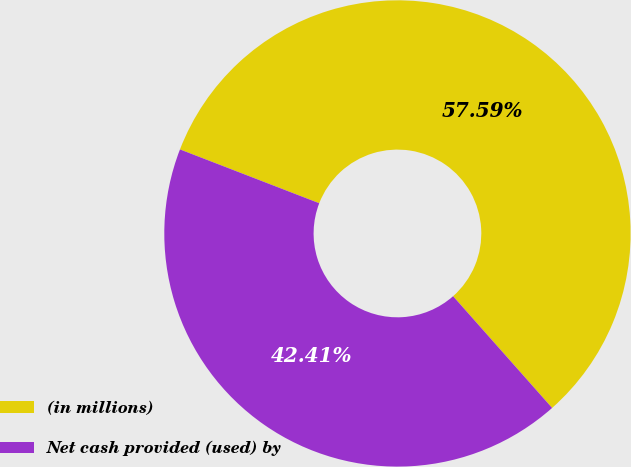Convert chart to OTSL. <chart><loc_0><loc_0><loc_500><loc_500><pie_chart><fcel>(in millions)<fcel>Net cash provided (used) by<nl><fcel>57.59%<fcel>42.41%<nl></chart> 